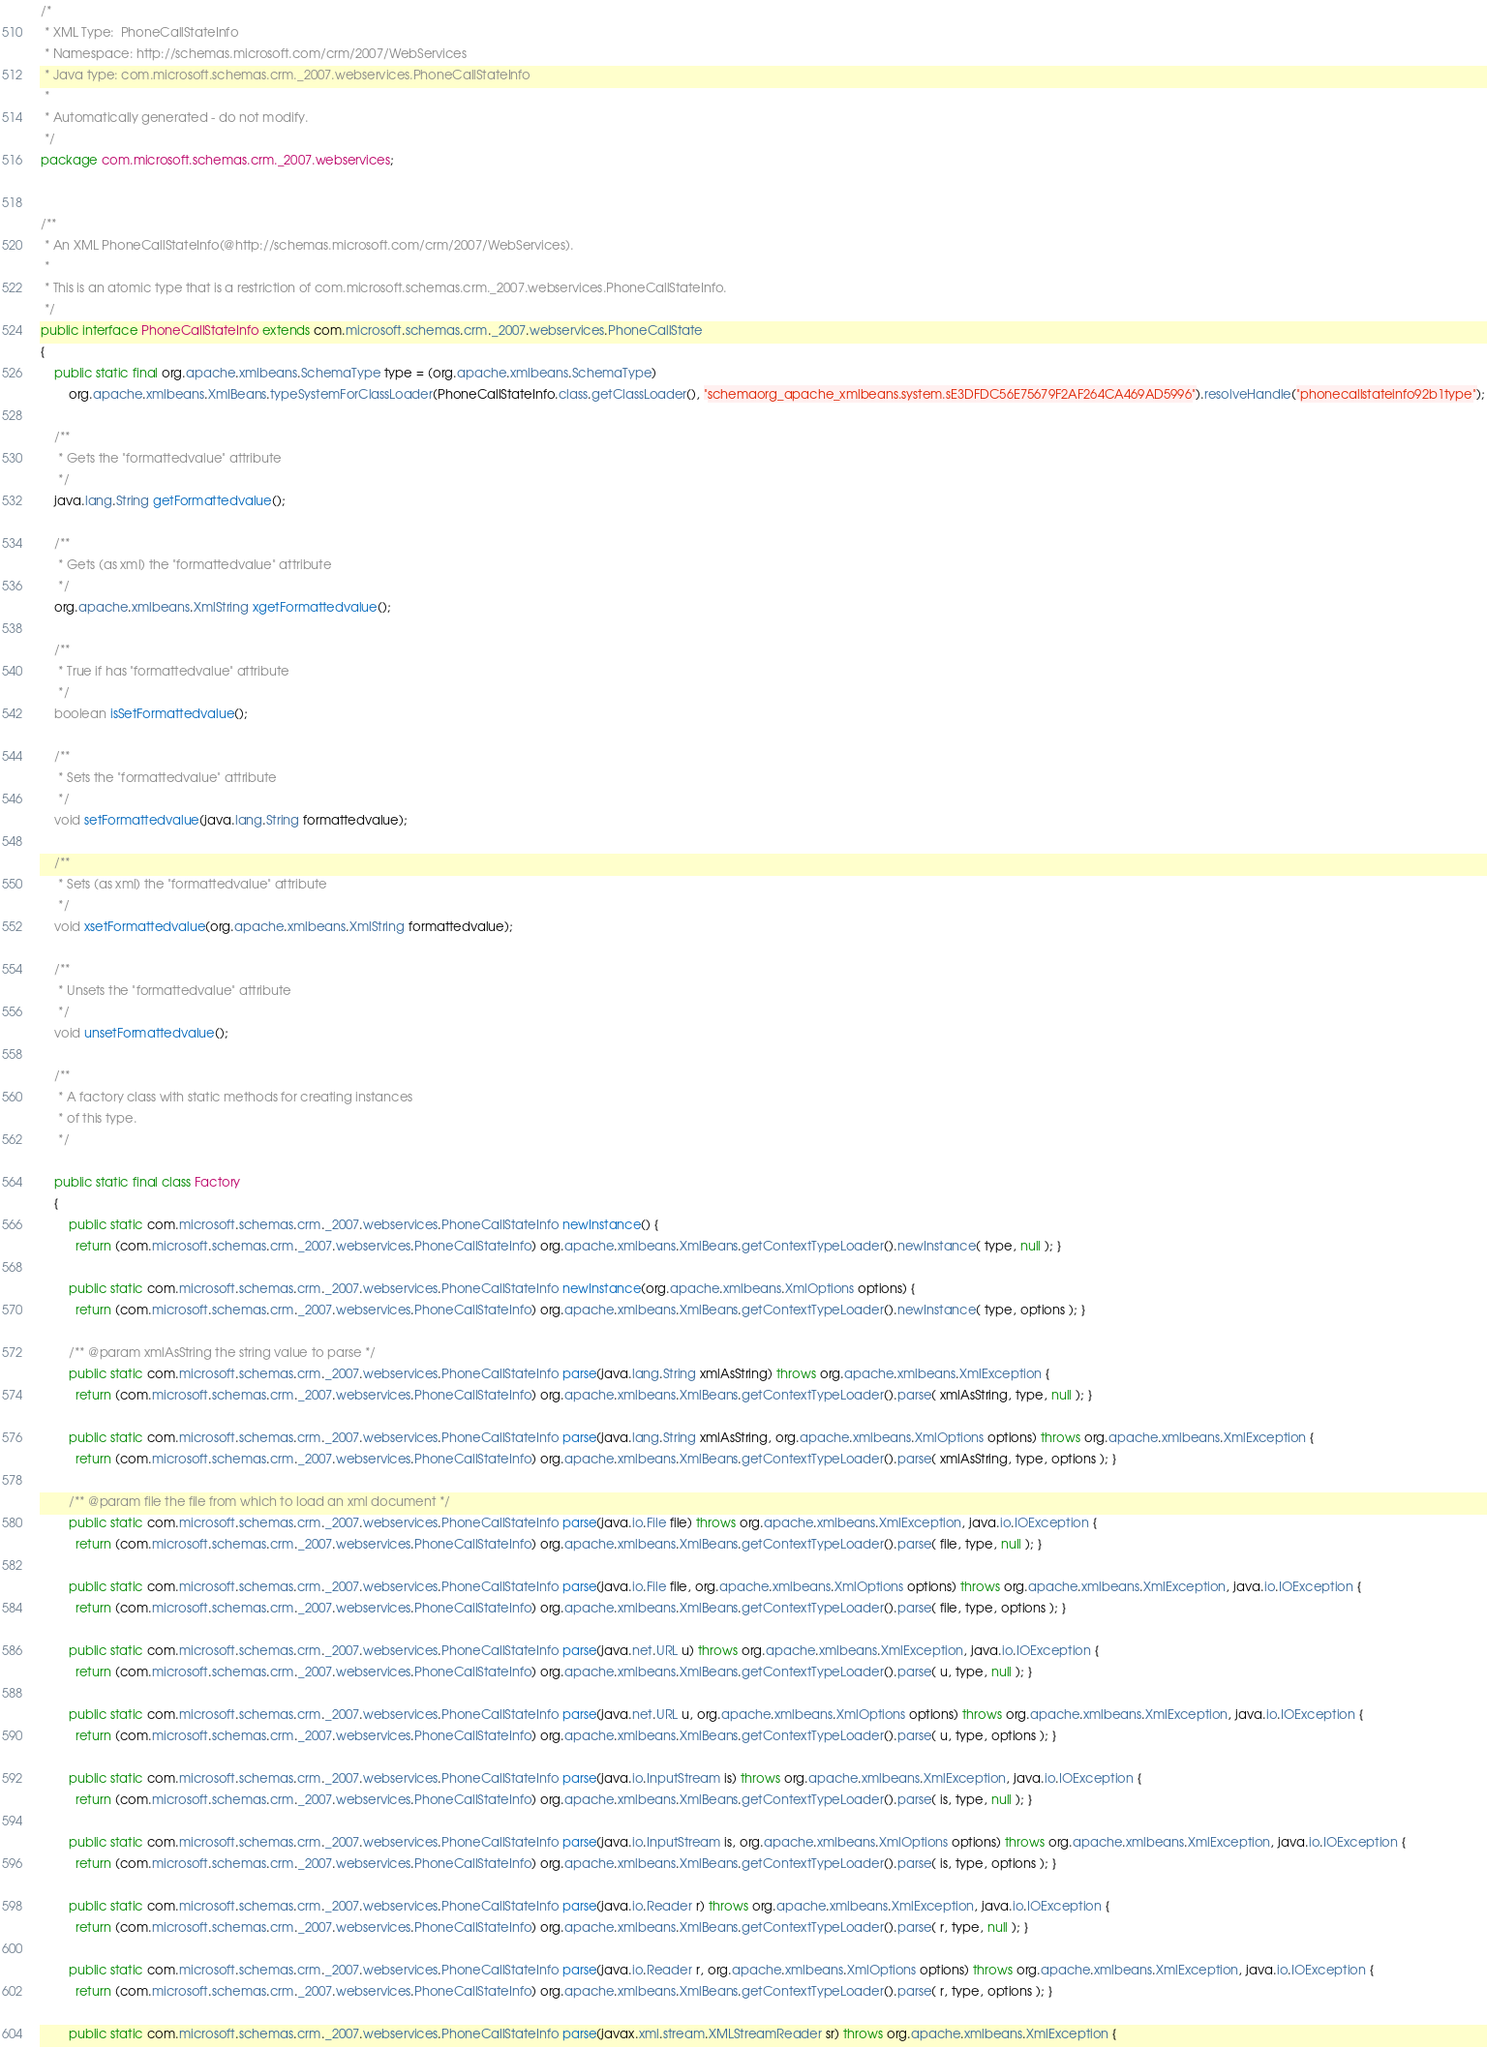<code> <loc_0><loc_0><loc_500><loc_500><_Java_>/*
 * XML Type:  PhoneCallStateInfo
 * Namespace: http://schemas.microsoft.com/crm/2007/WebServices
 * Java type: com.microsoft.schemas.crm._2007.webservices.PhoneCallStateInfo
 *
 * Automatically generated - do not modify.
 */
package com.microsoft.schemas.crm._2007.webservices;


/**
 * An XML PhoneCallStateInfo(@http://schemas.microsoft.com/crm/2007/WebServices).
 *
 * This is an atomic type that is a restriction of com.microsoft.schemas.crm._2007.webservices.PhoneCallStateInfo.
 */
public interface PhoneCallStateInfo extends com.microsoft.schemas.crm._2007.webservices.PhoneCallState
{
    public static final org.apache.xmlbeans.SchemaType type = (org.apache.xmlbeans.SchemaType)
        org.apache.xmlbeans.XmlBeans.typeSystemForClassLoader(PhoneCallStateInfo.class.getClassLoader(), "schemaorg_apache_xmlbeans.system.sE3DFDC56E75679F2AF264CA469AD5996").resolveHandle("phonecallstateinfo92b1type");
    
    /**
     * Gets the "formattedvalue" attribute
     */
    java.lang.String getFormattedvalue();
    
    /**
     * Gets (as xml) the "formattedvalue" attribute
     */
    org.apache.xmlbeans.XmlString xgetFormattedvalue();
    
    /**
     * True if has "formattedvalue" attribute
     */
    boolean isSetFormattedvalue();
    
    /**
     * Sets the "formattedvalue" attribute
     */
    void setFormattedvalue(java.lang.String formattedvalue);
    
    /**
     * Sets (as xml) the "formattedvalue" attribute
     */
    void xsetFormattedvalue(org.apache.xmlbeans.XmlString formattedvalue);
    
    /**
     * Unsets the "formattedvalue" attribute
     */
    void unsetFormattedvalue();
    
    /**
     * A factory class with static methods for creating instances
     * of this type.
     */
    
    public static final class Factory
    {
        public static com.microsoft.schemas.crm._2007.webservices.PhoneCallStateInfo newInstance() {
          return (com.microsoft.schemas.crm._2007.webservices.PhoneCallStateInfo) org.apache.xmlbeans.XmlBeans.getContextTypeLoader().newInstance( type, null ); }
        
        public static com.microsoft.schemas.crm._2007.webservices.PhoneCallStateInfo newInstance(org.apache.xmlbeans.XmlOptions options) {
          return (com.microsoft.schemas.crm._2007.webservices.PhoneCallStateInfo) org.apache.xmlbeans.XmlBeans.getContextTypeLoader().newInstance( type, options ); }
        
        /** @param xmlAsString the string value to parse */
        public static com.microsoft.schemas.crm._2007.webservices.PhoneCallStateInfo parse(java.lang.String xmlAsString) throws org.apache.xmlbeans.XmlException {
          return (com.microsoft.schemas.crm._2007.webservices.PhoneCallStateInfo) org.apache.xmlbeans.XmlBeans.getContextTypeLoader().parse( xmlAsString, type, null ); }
        
        public static com.microsoft.schemas.crm._2007.webservices.PhoneCallStateInfo parse(java.lang.String xmlAsString, org.apache.xmlbeans.XmlOptions options) throws org.apache.xmlbeans.XmlException {
          return (com.microsoft.schemas.crm._2007.webservices.PhoneCallStateInfo) org.apache.xmlbeans.XmlBeans.getContextTypeLoader().parse( xmlAsString, type, options ); }
        
        /** @param file the file from which to load an xml document */
        public static com.microsoft.schemas.crm._2007.webservices.PhoneCallStateInfo parse(java.io.File file) throws org.apache.xmlbeans.XmlException, java.io.IOException {
          return (com.microsoft.schemas.crm._2007.webservices.PhoneCallStateInfo) org.apache.xmlbeans.XmlBeans.getContextTypeLoader().parse( file, type, null ); }
        
        public static com.microsoft.schemas.crm._2007.webservices.PhoneCallStateInfo parse(java.io.File file, org.apache.xmlbeans.XmlOptions options) throws org.apache.xmlbeans.XmlException, java.io.IOException {
          return (com.microsoft.schemas.crm._2007.webservices.PhoneCallStateInfo) org.apache.xmlbeans.XmlBeans.getContextTypeLoader().parse( file, type, options ); }
        
        public static com.microsoft.schemas.crm._2007.webservices.PhoneCallStateInfo parse(java.net.URL u) throws org.apache.xmlbeans.XmlException, java.io.IOException {
          return (com.microsoft.schemas.crm._2007.webservices.PhoneCallStateInfo) org.apache.xmlbeans.XmlBeans.getContextTypeLoader().parse( u, type, null ); }
        
        public static com.microsoft.schemas.crm._2007.webservices.PhoneCallStateInfo parse(java.net.URL u, org.apache.xmlbeans.XmlOptions options) throws org.apache.xmlbeans.XmlException, java.io.IOException {
          return (com.microsoft.schemas.crm._2007.webservices.PhoneCallStateInfo) org.apache.xmlbeans.XmlBeans.getContextTypeLoader().parse( u, type, options ); }
        
        public static com.microsoft.schemas.crm._2007.webservices.PhoneCallStateInfo parse(java.io.InputStream is) throws org.apache.xmlbeans.XmlException, java.io.IOException {
          return (com.microsoft.schemas.crm._2007.webservices.PhoneCallStateInfo) org.apache.xmlbeans.XmlBeans.getContextTypeLoader().parse( is, type, null ); }
        
        public static com.microsoft.schemas.crm._2007.webservices.PhoneCallStateInfo parse(java.io.InputStream is, org.apache.xmlbeans.XmlOptions options) throws org.apache.xmlbeans.XmlException, java.io.IOException {
          return (com.microsoft.schemas.crm._2007.webservices.PhoneCallStateInfo) org.apache.xmlbeans.XmlBeans.getContextTypeLoader().parse( is, type, options ); }
        
        public static com.microsoft.schemas.crm._2007.webservices.PhoneCallStateInfo parse(java.io.Reader r) throws org.apache.xmlbeans.XmlException, java.io.IOException {
          return (com.microsoft.schemas.crm._2007.webservices.PhoneCallStateInfo) org.apache.xmlbeans.XmlBeans.getContextTypeLoader().parse( r, type, null ); }
        
        public static com.microsoft.schemas.crm._2007.webservices.PhoneCallStateInfo parse(java.io.Reader r, org.apache.xmlbeans.XmlOptions options) throws org.apache.xmlbeans.XmlException, java.io.IOException {
          return (com.microsoft.schemas.crm._2007.webservices.PhoneCallStateInfo) org.apache.xmlbeans.XmlBeans.getContextTypeLoader().parse( r, type, options ); }
        
        public static com.microsoft.schemas.crm._2007.webservices.PhoneCallStateInfo parse(javax.xml.stream.XMLStreamReader sr) throws org.apache.xmlbeans.XmlException {</code> 